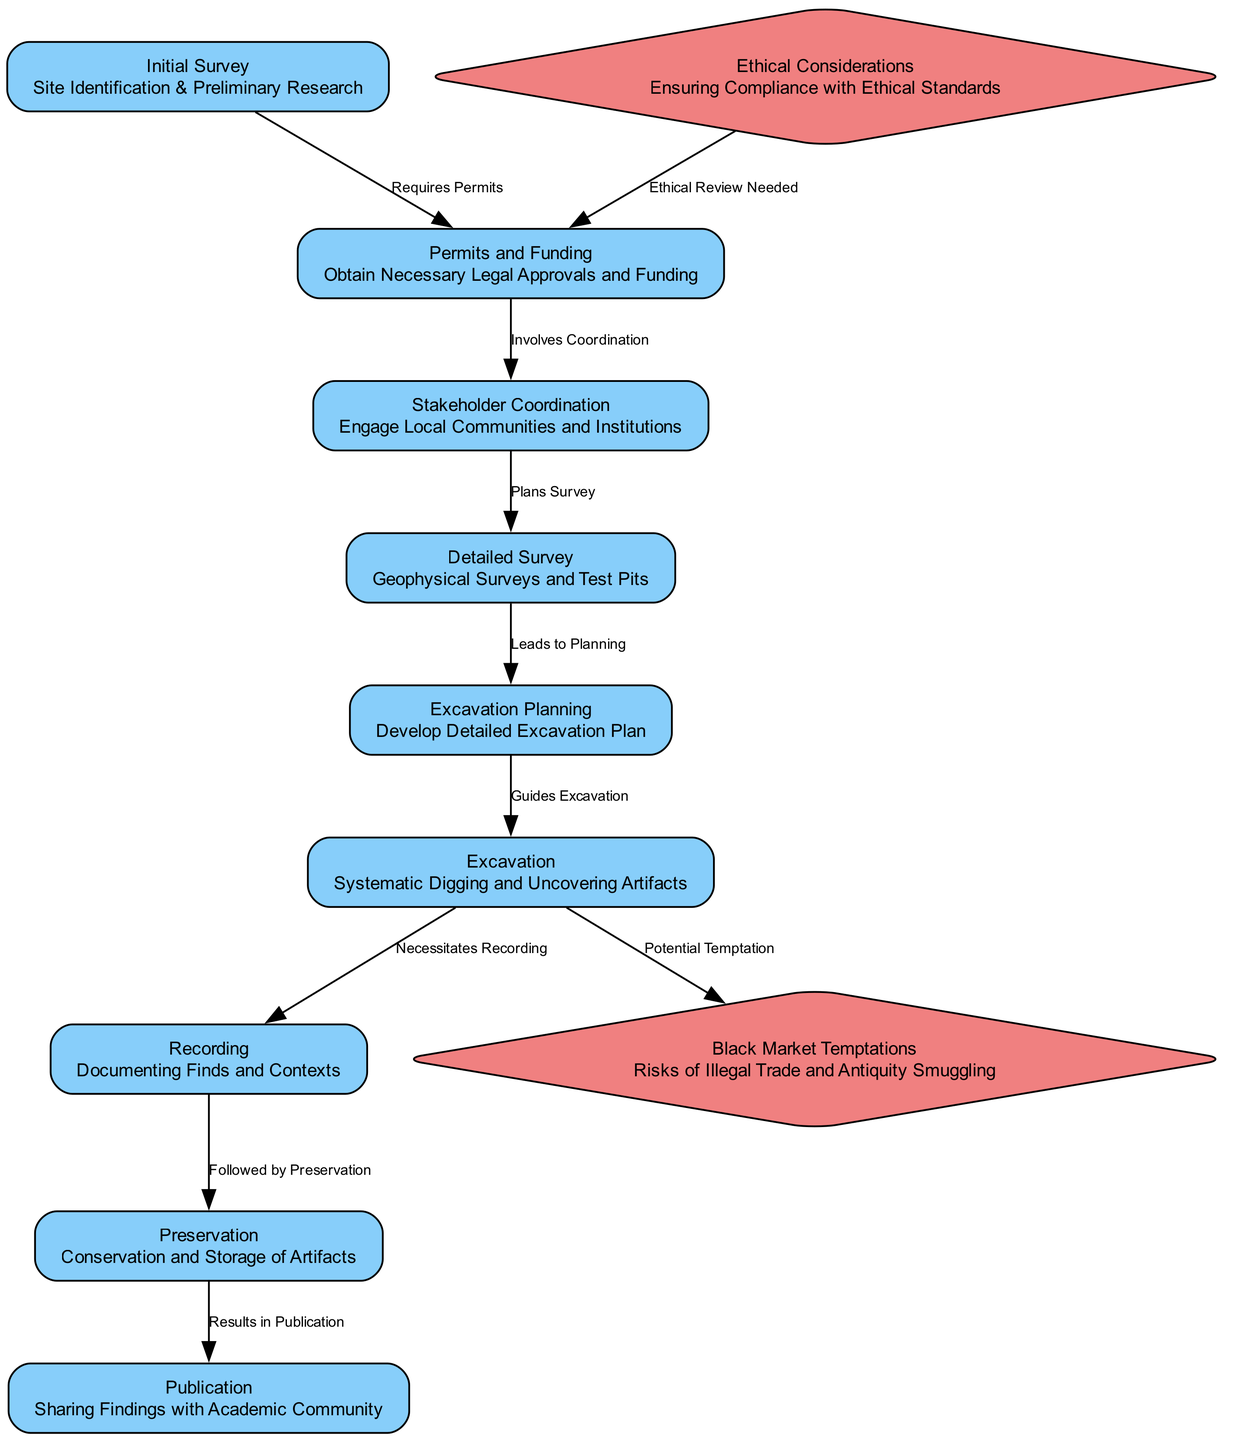What is the first step in the excavation workflow? The diagram lists "Initial Survey" as the first node, indicating that it is the first step in the excavation workflow.
Answer: Initial Survey How many main steps are there in the excavation process? By counting the nodes labeled with steps in the diagram, I find there are eight main steps from Initial Survey to Publication.
Answer: 8 What node follows Excavation in the workflow? The diagram shows a direct connection from "Excavation" to "Recording," indicating that Recording follows Excavation.
Answer: Recording What ethical considerations are required before obtaining permits? The diagram indicates that "Ethical Considerations" must precede "Permits and Funding," denoting that ethical reviews are necessary prior to obtaining permits.
Answer: Ethical Review Needed What potential temptation arises during the Excavation phase? The diagram connects "Excavation" to "Black Market Temptations," highlighting the risk of illegal trade and antiquity smuggling during this phase.
Answer: Black Market Temptations Which step involves engaging local communities? The diagram specifies "Stakeholder Coordination" as the step where engaging local communities and institutions occurs.
Answer: Stakeholder Coordination How do permits relate to the initial survey? The diagram indicates that the "Initial Survey" requires permits, showing a direct relationship between these two steps in the workflow.
Answer: Requires Permits What is the final step after preservation of artifacts? The diagram indicates that the step following "Preservation" is "Publication," which involves sharing findings with the academic community.
Answer: Publication How many nodes are labeled with ethical considerations? The diagram shows two nodes, "Ethical Considerations" and "Black Market Temptations," explicitly highlighting these aspects in the excavation workflow.
Answer: 2 